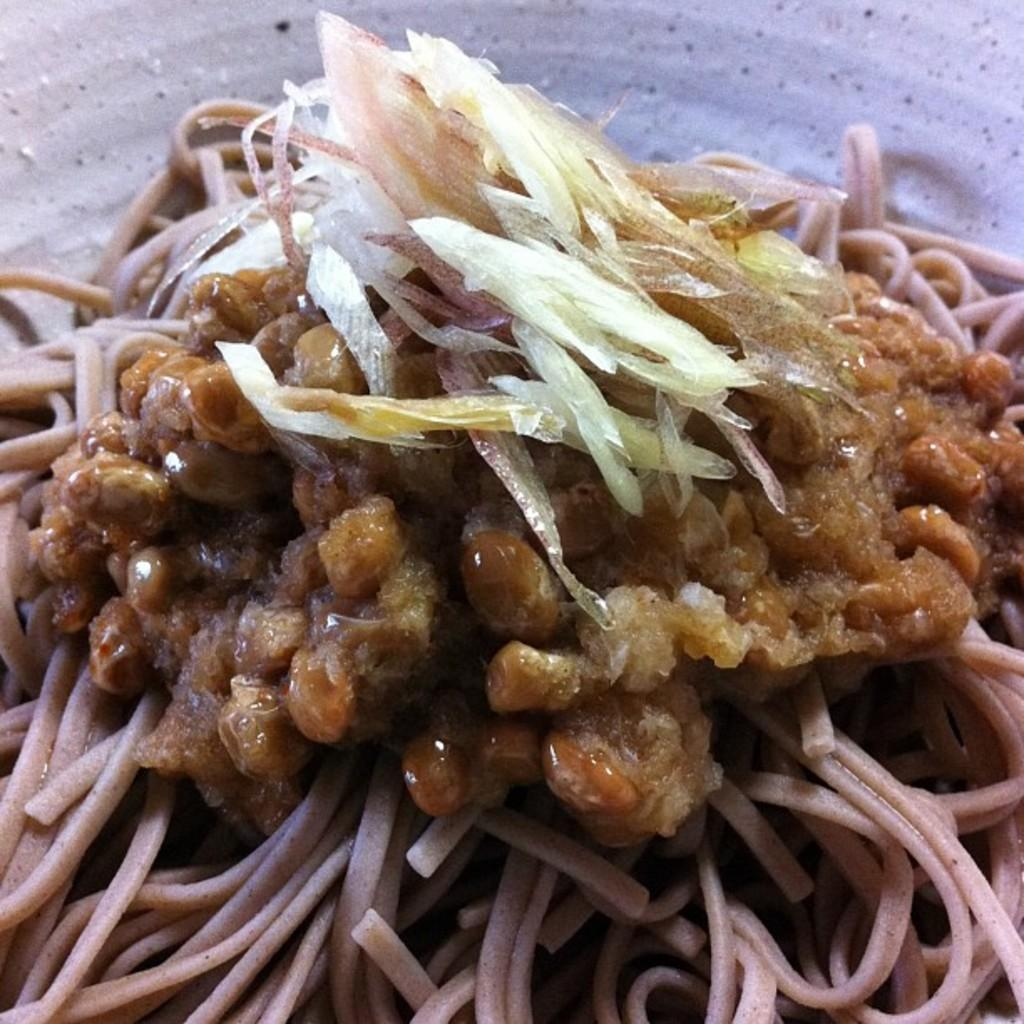What is present in the image related to food? There is food in the image. How is the food arranged or contained in the image? The food is kept in a plate. What time of day is depicted in the image, and what role does the flame play in the scene? There is no indication of time of day or any flame present in the image. 